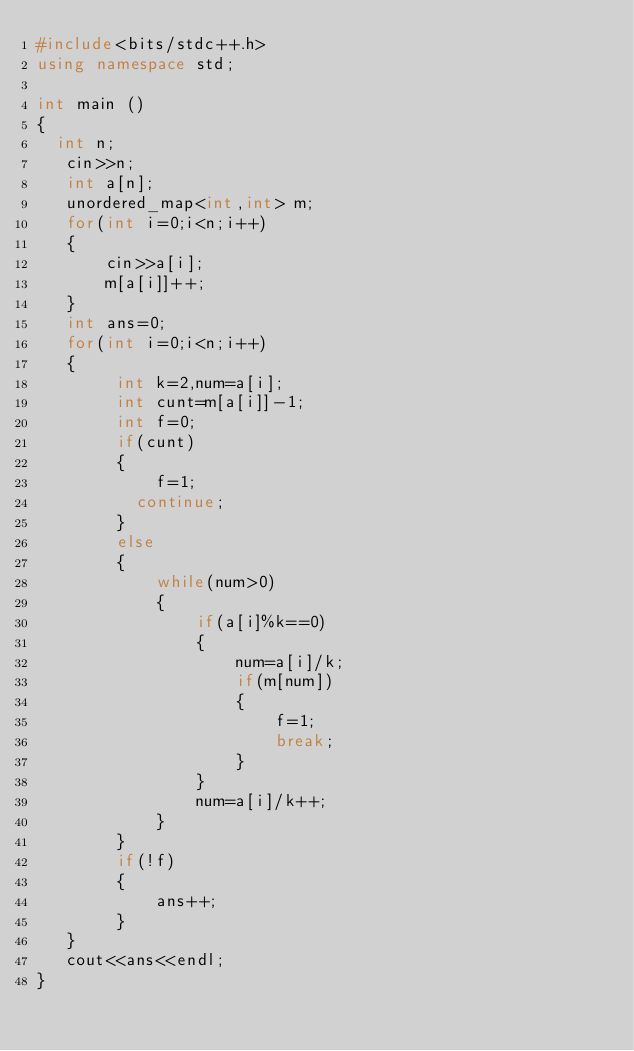<code> <loc_0><loc_0><loc_500><loc_500><_C++_>#include<bits/stdc++.h>
using namespace std;

int main ()
{
  int n;
   cin>>n;
   int a[n];
   unordered_map<int,int> m;
   for(int i=0;i<n;i++)
   {
       cin>>a[i];
       m[a[i]]++;
   }
   int ans=0;
   for(int i=0;i<n;i++)
   {
        int k=2,num=a[i];
        int cunt=m[a[i]]-1;
        int f=0;
        if(cunt)
        {
            f=1;
          continue;
        }
        else
        {
            while(num>0)
            {
                if(a[i]%k==0)
                {
                    num=a[i]/k;
                    if(m[num])
                    {
                        f=1;
                        break;
                    }
                }
                num=a[i]/k++;
            }
        }
        if(!f)
        {
            ans++;
        }
   }
   cout<<ans<<endl;
}
</code> 